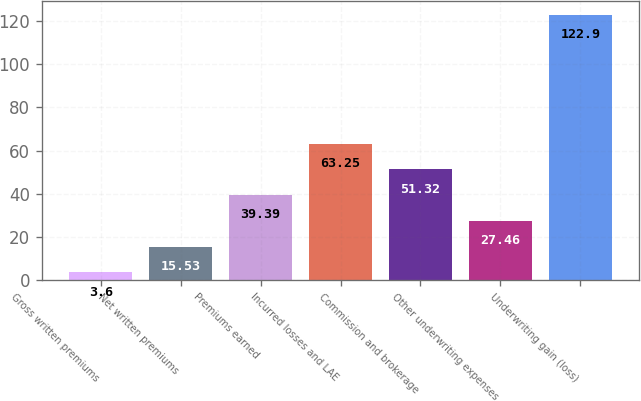Convert chart. <chart><loc_0><loc_0><loc_500><loc_500><bar_chart><fcel>Gross written premiums<fcel>Net written premiums<fcel>Premiums earned<fcel>Incurred losses and LAE<fcel>Commission and brokerage<fcel>Other underwriting expenses<fcel>Underwriting gain (loss)<nl><fcel>3.6<fcel>15.53<fcel>39.39<fcel>63.25<fcel>51.32<fcel>27.46<fcel>122.9<nl></chart> 